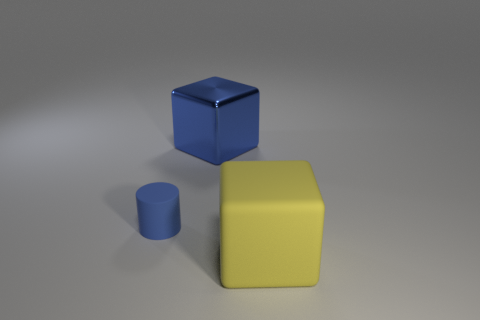There is another object that is the same shape as the yellow rubber object; what color is it?
Offer a very short reply. Blue. Is the size of the yellow thing the same as the metal block?
Give a very brief answer. Yes. What is the large thing that is behind the big rubber cube made of?
Make the answer very short. Metal. How many other things are the same shape as the small blue thing?
Make the answer very short. 0. Is the shape of the large metal object the same as the yellow object?
Ensure brevity in your answer.  Yes. Are there any small rubber cylinders to the left of the blue block?
Offer a very short reply. Yes. How many objects are small blue cylinders or blue things?
Make the answer very short. 2. How many other things are there of the same size as the shiny thing?
Your answer should be compact. 1. How many objects are behind the large matte object and to the right of the blue rubber cylinder?
Your answer should be very brief. 1. There is a block to the right of the metal block; does it have the same size as the blue metallic block that is on the right side of the cylinder?
Offer a very short reply. Yes. 